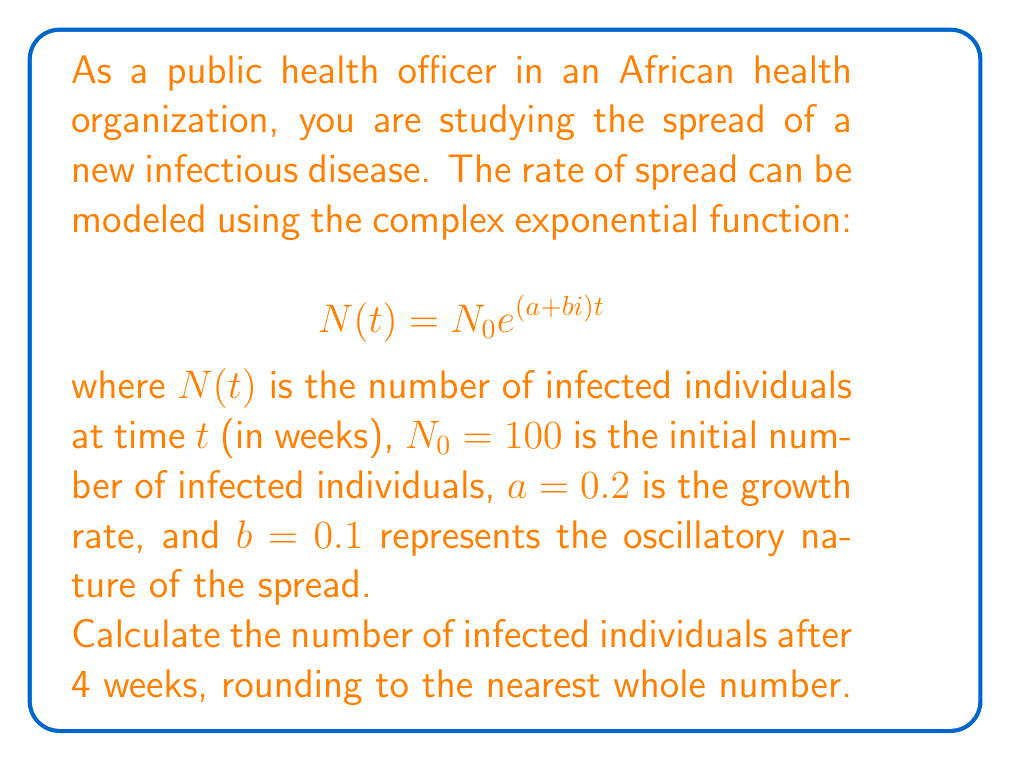Can you answer this question? Let's approach this step-by-step:

1) We are given the function $N(t) = N_0 e^{(a+bi)t}$ with:
   $N_0 = 100$
   $a = 0.2$
   $b = 0.1$
   $t = 4$ weeks

2) Substituting these values into the equation:
   $N(4) = 100 e^{(0.2+0.1i)4}$

3) Simplify the exponent:
   $N(4) = 100 e^{0.8+0.4i}$

4) To evaluate this, we can use Euler's formula: $e^{x+yi} = e^x(\cos y + i\sin y)$

5) In our case, $x = 0.8$ and $y = 0.4$:
   $N(4) = 100 e^{0.8}(\cos 0.4 + i\sin 0.4)$

6) Calculate $e^{0.8} \approx 2.2255$

7) $\cos 0.4 \approx 0.9211$ and $\sin 0.4 \approx 0.3894$

8) Substituting these values:
   $N(4) = 100 \cdot 2.2255 \cdot (0.9211 + 0.3894i)$

9) Multiply:
   $N(4) = 222.55 \cdot (0.9211 + 0.3894i)$
   $N(4) = 205.0003 + 86.6610i$

10) The number of infected individuals is represented by the magnitude of this complex number:
    $|N(4)| = \sqrt{205.0003^2 + 86.6610^2} \approx 222.55$

11) Rounding to the nearest whole number: 223
Answer: 223 infected individuals 